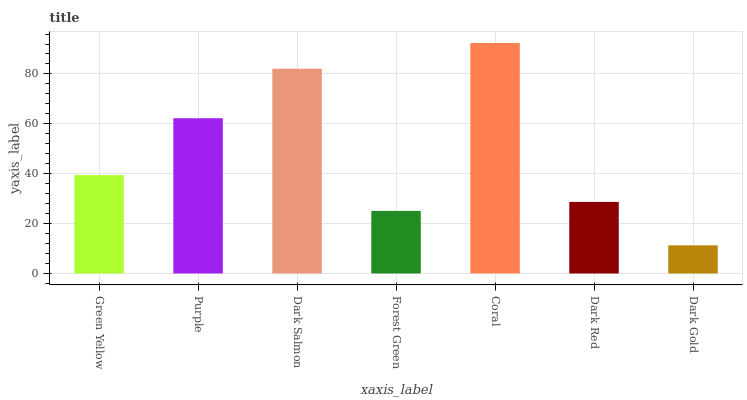Is Dark Gold the minimum?
Answer yes or no. Yes. Is Coral the maximum?
Answer yes or no. Yes. Is Purple the minimum?
Answer yes or no. No. Is Purple the maximum?
Answer yes or no. No. Is Purple greater than Green Yellow?
Answer yes or no. Yes. Is Green Yellow less than Purple?
Answer yes or no. Yes. Is Green Yellow greater than Purple?
Answer yes or no. No. Is Purple less than Green Yellow?
Answer yes or no. No. Is Green Yellow the high median?
Answer yes or no. Yes. Is Green Yellow the low median?
Answer yes or no. Yes. Is Dark Red the high median?
Answer yes or no. No. Is Forest Green the low median?
Answer yes or no. No. 